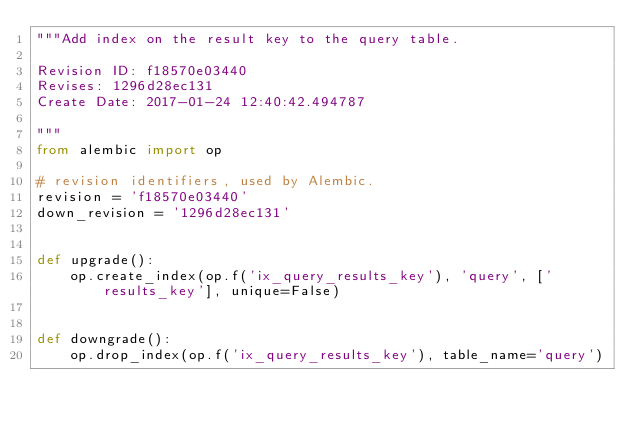Convert code to text. <code><loc_0><loc_0><loc_500><loc_500><_Python_>"""Add index on the result key to the query table.

Revision ID: f18570e03440
Revises: 1296d28ec131
Create Date: 2017-01-24 12:40:42.494787

"""
from alembic import op

# revision identifiers, used by Alembic.
revision = 'f18570e03440'
down_revision = '1296d28ec131'


def upgrade():
    op.create_index(op.f('ix_query_results_key'), 'query', ['results_key'], unique=False)


def downgrade():
    op.drop_index(op.f('ix_query_results_key'), table_name='query')
</code> 